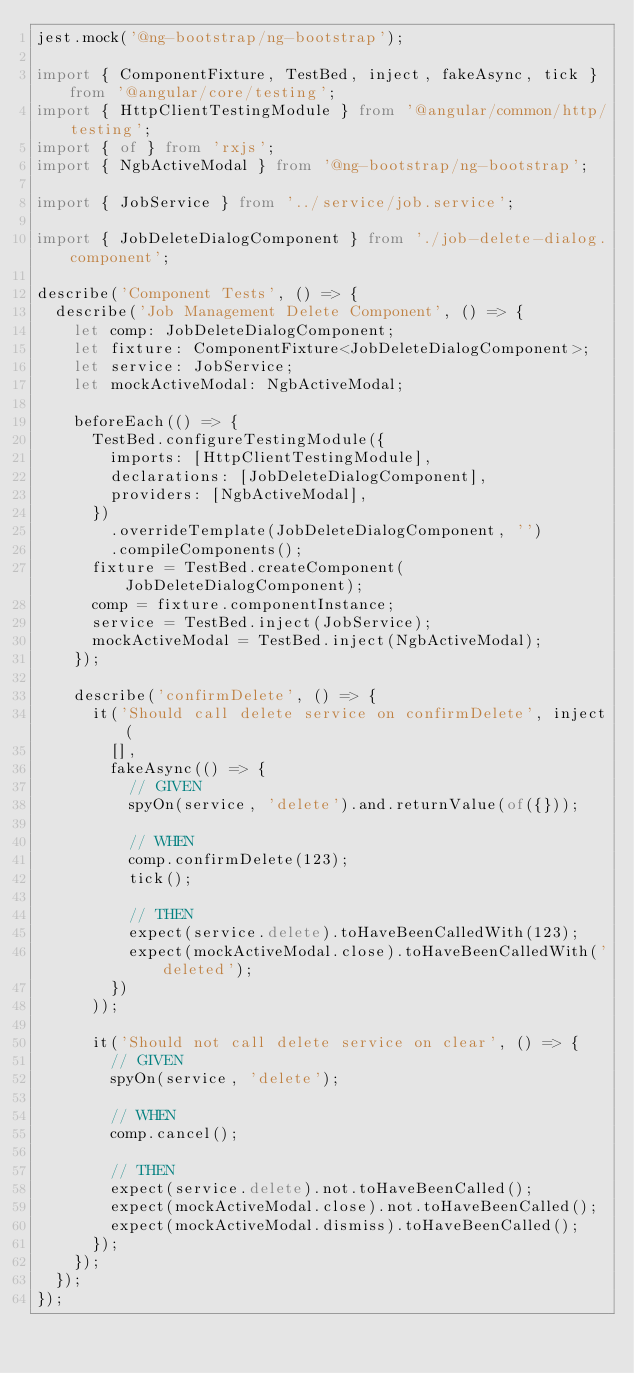<code> <loc_0><loc_0><loc_500><loc_500><_TypeScript_>jest.mock('@ng-bootstrap/ng-bootstrap');

import { ComponentFixture, TestBed, inject, fakeAsync, tick } from '@angular/core/testing';
import { HttpClientTestingModule } from '@angular/common/http/testing';
import { of } from 'rxjs';
import { NgbActiveModal } from '@ng-bootstrap/ng-bootstrap';

import { JobService } from '../service/job.service';

import { JobDeleteDialogComponent } from './job-delete-dialog.component';

describe('Component Tests', () => {
  describe('Job Management Delete Component', () => {
    let comp: JobDeleteDialogComponent;
    let fixture: ComponentFixture<JobDeleteDialogComponent>;
    let service: JobService;
    let mockActiveModal: NgbActiveModal;

    beforeEach(() => {
      TestBed.configureTestingModule({
        imports: [HttpClientTestingModule],
        declarations: [JobDeleteDialogComponent],
        providers: [NgbActiveModal],
      })
        .overrideTemplate(JobDeleteDialogComponent, '')
        .compileComponents();
      fixture = TestBed.createComponent(JobDeleteDialogComponent);
      comp = fixture.componentInstance;
      service = TestBed.inject(JobService);
      mockActiveModal = TestBed.inject(NgbActiveModal);
    });

    describe('confirmDelete', () => {
      it('Should call delete service on confirmDelete', inject(
        [],
        fakeAsync(() => {
          // GIVEN
          spyOn(service, 'delete').and.returnValue(of({}));

          // WHEN
          comp.confirmDelete(123);
          tick();

          // THEN
          expect(service.delete).toHaveBeenCalledWith(123);
          expect(mockActiveModal.close).toHaveBeenCalledWith('deleted');
        })
      ));

      it('Should not call delete service on clear', () => {
        // GIVEN
        spyOn(service, 'delete');

        // WHEN
        comp.cancel();

        // THEN
        expect(service.delete).not.toHaveBeenCalled();
        expect(mockActiveModal.close).not.toHaveBeenCalled();
        expect(mockActiveModal.dismiss).toHaveBeenCalled();
      });
    });
  });
});
</code> 